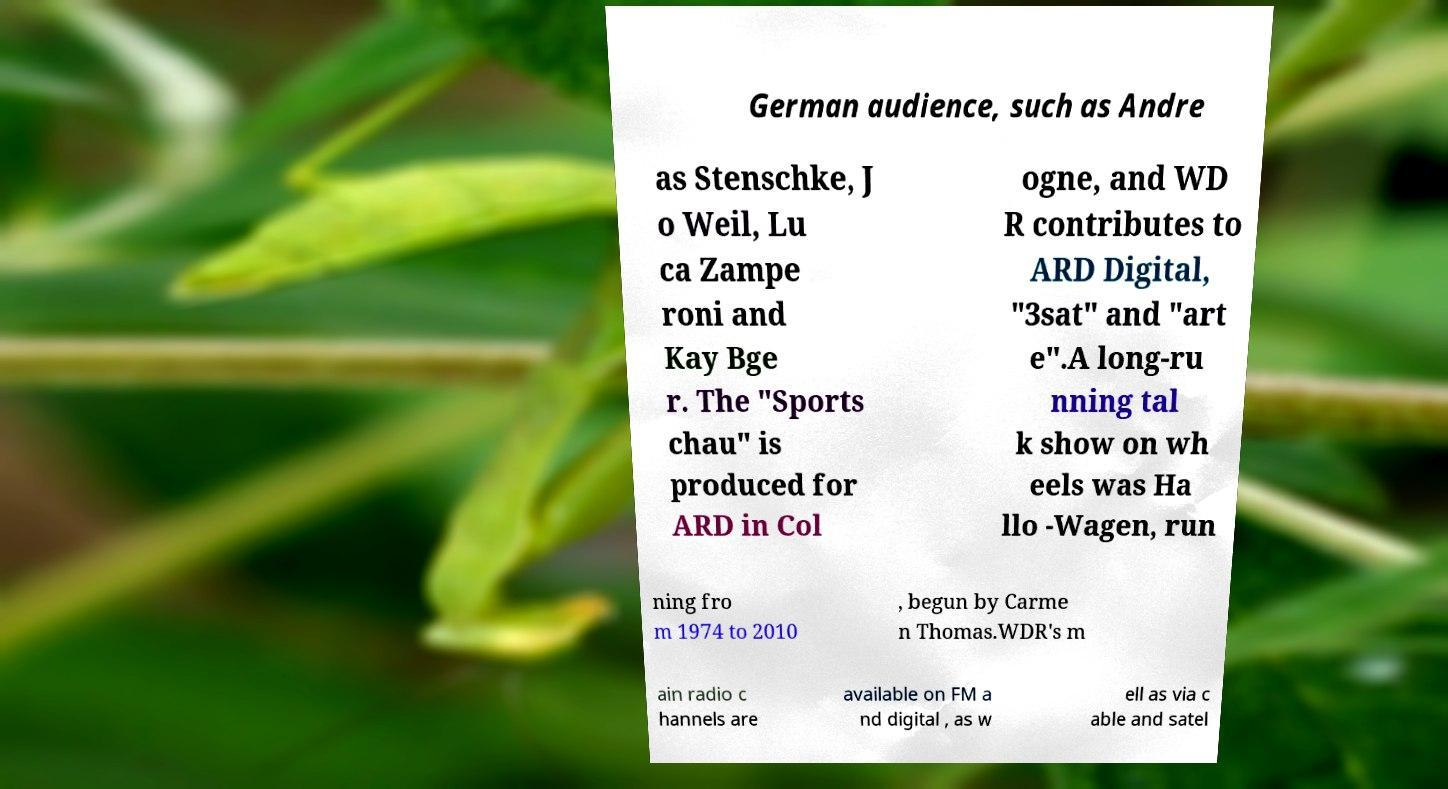Could you extract and type out the text from this image? German audience, such as Andre as Stenschke, J o Weil, Lu ca Zampe roni and Kay Bge r. The "Sports chau" is produced for ARD in Col ogne, and WD R contributes to ARD Digital, "3sat" and "art e".A long-ru nning tal k show on wh eels was Ha llo -Wagen, run ning fro m 1974 to 2010 , begun by Carme n Thomas.WDR's m ain radio c hannels are available on FM a nd digital , as w ell as via c able and satel 